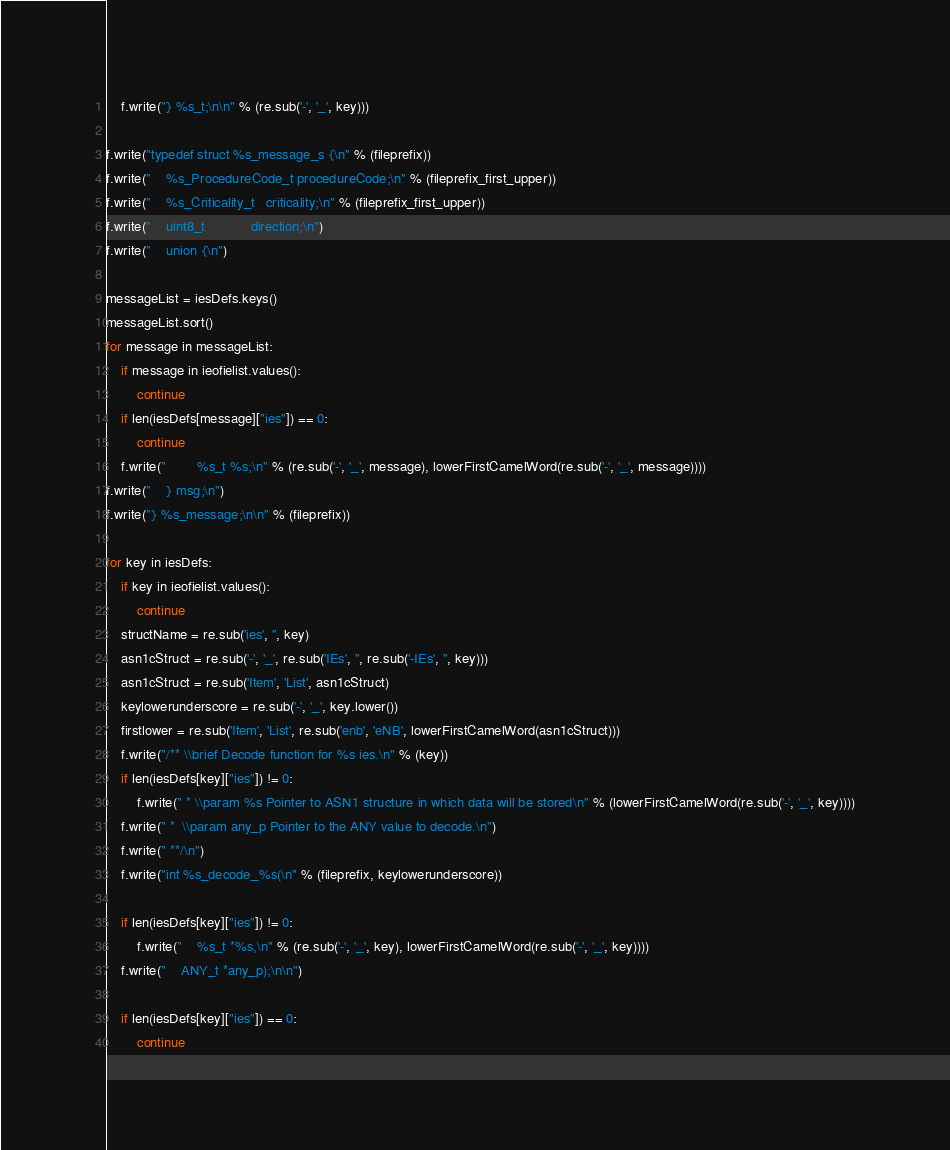Convert code to text. <code><loc_0><loc_0><loc_500><loc_500><_Python_>
    f.write("} %s_t;\n\n" % (re.sub('-', '_', key)))

f.write("typedef struct %s_message_s {\n" % (fileprefix))
f.write("    %s_ProcedureCode_t procedureCode;\n" % (fileprefix_first_upper))
f.write("    %s_Criticality_t   criticality;\n" % (fileprefix_first_upper))
f.write("    uint8_t            direction;\n")
f.write("    union {\n")

messageList = iesDefs.keys()
messageList.sort()
for message in messageList:
    if message in ieofielist.values():
        continue
    if len(iesDefs[message]["ies"]) == 0:
        continue
    f.write("        %s_t %s;\n" % (re.sub('-', '_', message), lowerFirstCamelWord(re.sub('-', '_', message))))
f.write("    } msg;\n")
f.write("} %s_message;\n\n" % (fileprefix))

for key in iesDefs:
    if key in ieofielist.values():
        continue
    structName = re.sub('ies', '', key)
    asn1cStruct = re.sub('-', '_', re.sub('IEs', '', re.sub('-IEs', '', key)))
    asn1cStruct = re.sub('Item', 'List', asn1cStruct)
    keylowerunderscore = re.sub('-', '_', key.lower())
    firstlower = re.sub('Item', 'List', re.sub('enb', 'eNB', lowerFirstCamelWord(asn1cStruct)))
    f.write("/** \\brief Decode function for %s ies.\n" % (key))
    if len(iesDefs[key]["ies"]) != 0:
        f.write(" * \\param %s Pointer to ASN1 structure in which data will be stored\n" % (lowerFirstCamelWord(re.sub('-', '_', key))))
    f.write(" *  \\param any_p Pointer to the ANY value to decode.\n")
    f.write(" **/\n")
    f.write("int %s_decode_%s(\n" % (fileprefix, keylowerunderscore))

    if len(iesDefs[key]["ies"]) != 0:
        f.write("    %s_t *%s,\n" % (re.sub('-', '_', key), lowerFirstCamelWord(re.sub('-', '_', key))))
    f.write("    ANY_t *any_p);\n\n")

    if len(iesDefs[key]["ies"]) == 0:
        continue
</code> 